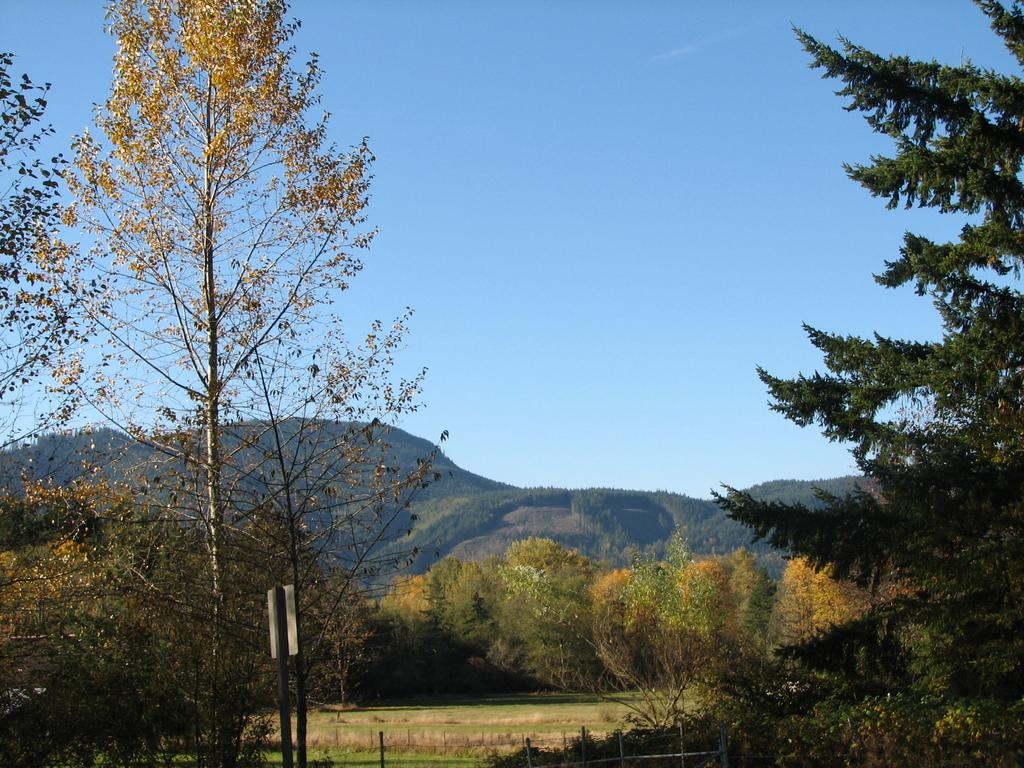What type of vegetation can be seen in the image? There are trees in the image. What geographical feature is present in the image? There is a mountain in the image. What part of the natural environment is visible in the image? The sky is visible in the image. What grade of beetle can be seen crawling on the mountain in the image? There are no beetles present in the image, and therefore no grade of beetle can be observed. How many people are in the group that is standing near the trees in the image? There is no group of people present in the image; only trees, a mountain, and the sky are visible. 